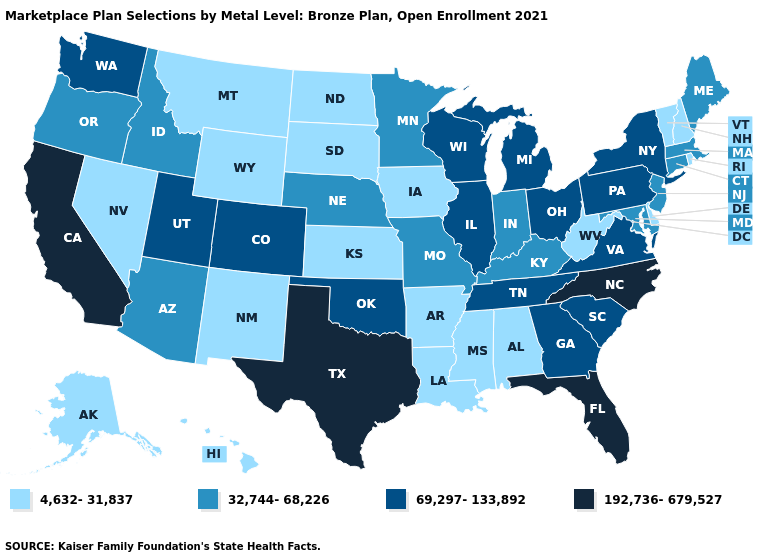What is the value of West Virginia?
Be succinct. 4,632-31,837. Does New Mexico have the lowest value in the USA?
Short answer required. Yes. Among the states that border Georgia , which have the highest value?
Keep it brief. Florida, North Carolina. Does the first symbol in the legend represent the smallest category?
Answer briefly. Yes. Which states have the lowest value in the USA?
Give a very brief answer. Alabama, Alaska, Arkansas, Delaware, Hawaii, Iowa, Kansas, Louisiana, Mississippi, Montana, Nevada, New Hampshire, New Mexico, North Dakota, Rhode Island, South Dakota, Vermont, West Virginia, Wyoming. Name the states that have a value in the range 4,632-31,837?
Quick response, please. Alabama, Alaska, Arkansas, Delaware, Hawaii, Iowa, Kansas, Louisiana, Mississippi, Montana, Nevada, New Hampshire, New Mexico, North Dakota, Rhode Island, South Dakota, Vermont, West Virginia, Wyoming. Which states hav the highest value in the West?
Concise answer only. California. Does Texas have the highest value in the USA?
Quick response, please. Yes. Does the first symbol in the legend represent the smallest category?
Give a very brief answer. Yes. Does Illinois have the highest value in the MidWest?
Be succinct. Yes. Among the states that border South Carolina , does North Carolina have the lowest value?
Quick response, please. No. Does Oregon have a higher value than North Dakota?
Write a very short answer. Yes. Name the states that have a value in the range 69,297-133,892?
Answer briefly. Colorado, Georgia, Illinois, Michigan, New York, Ohio, Oklahoma, Pennsylvania, South Carolina, Tennessee, Utah, Virginia, Washington, Wisconsin. What is the value of New Jersey?
Short answer required. 32,744-68,226. 